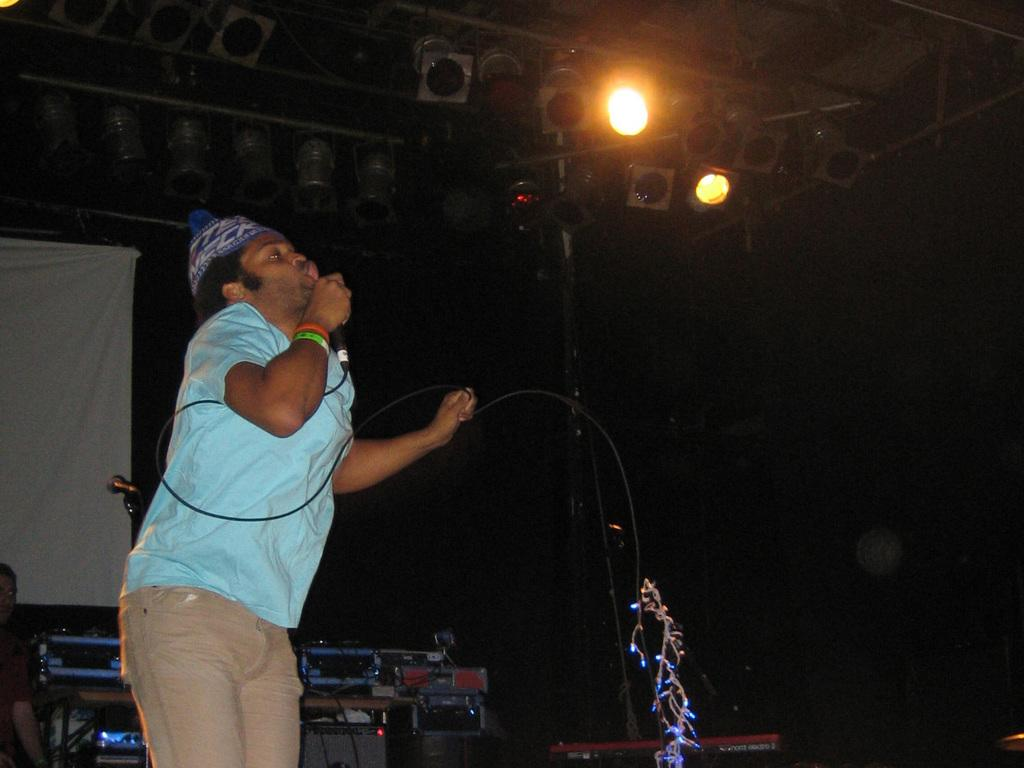Who is present in the image? There is a man in the image. What is the man holding in the image? The man is holding a microphone. What else can be seen in the image besides the man? There are musical instruments in the image. Can you describe the lighting in the image? There is a light in the image. What type of sweater is the government wearing in the image? There is no government or sweater present in the image. 